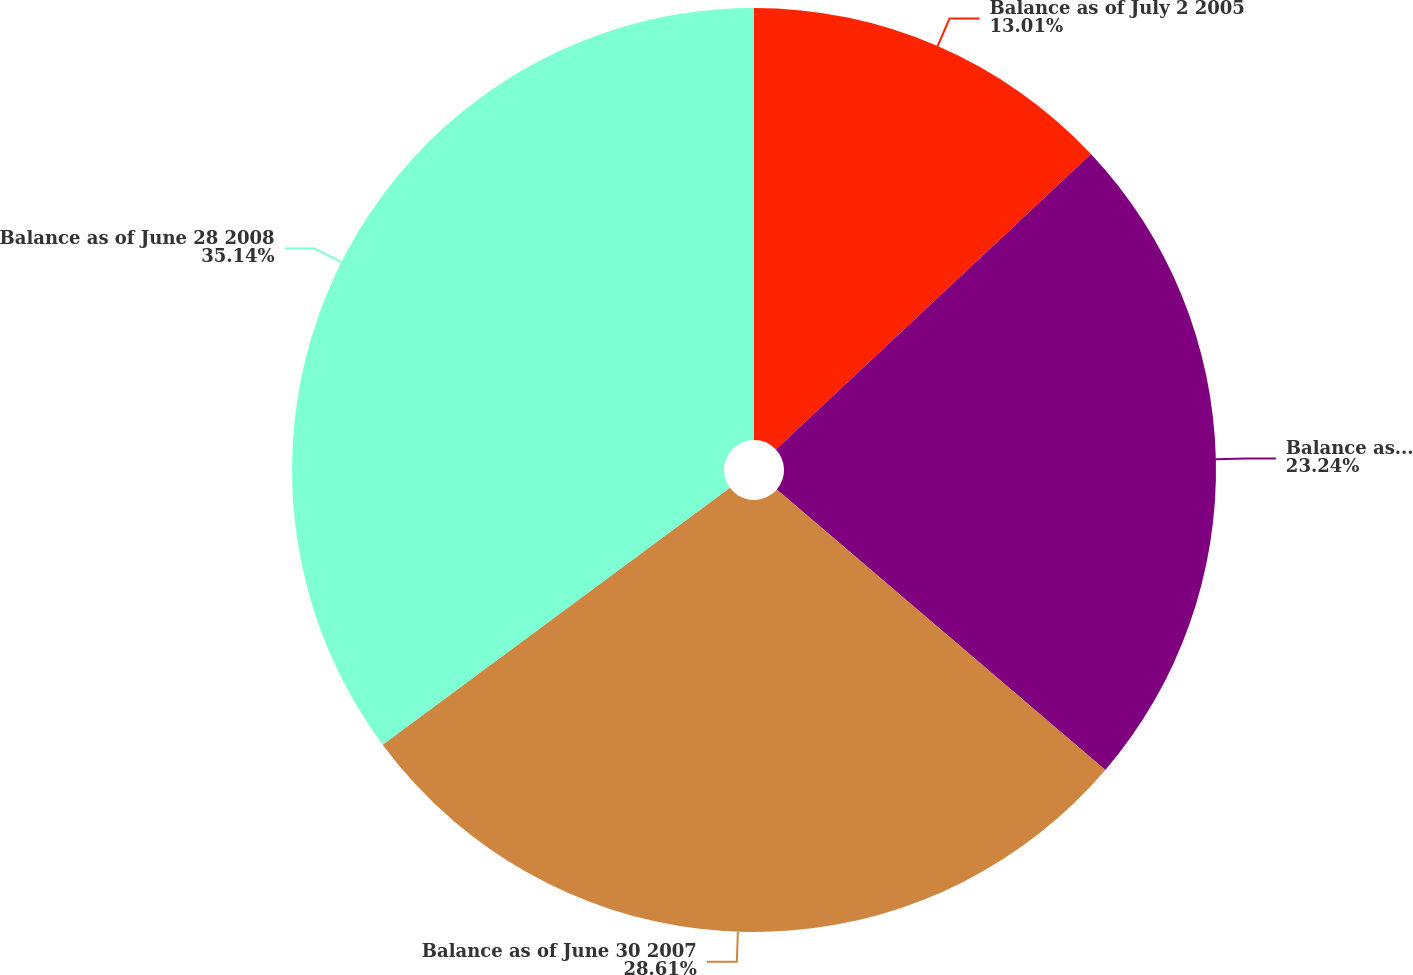Convert chart. <chart><loc_0><loc_0><loc_500><loc_500><pie_chart><fcel>Balance as of July 2 2005<fcel>Balance as of July 1 2006<fcel>Balance as of June 30 2007<fcel>Balance as of June 28 2008<nl><fcel>13.01%<fcel>23.24%<fcel>28.61%<fcel>35.14%<nl></chart> 